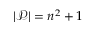<formula> <loc_0><loc_0><loc_500><loc_500>| { \mathcal { P } } | = n ^ { 2 } + 1</formula> 